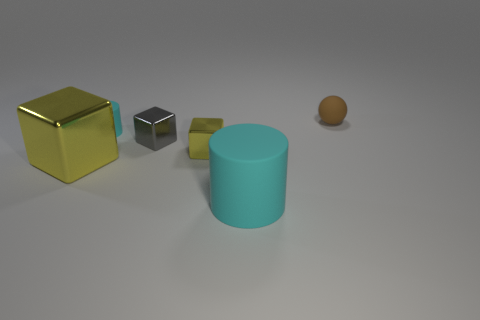Subtract all cyan cylinders. How many were subtracted if there are1cyan cylinders left? 1 Subtract all tiny yellow metal blocks. How many blocks are left? 2 Add 3 cylinders. How many objects exist? 9 Subtract all gray blocks. How many blocks are left? 2 Subtract all yellow spheres. How many yellow cylinders are left? 0 Subtract all brown objects. Subtract all cyan matte cylinders. How many objects are left? 3 Add 6 tiny yellow metallic things. How many tiny yellow metallic things are left? 7 Add 5 blue cylinders. How many blue cylinders exist? 5 Subtract 2 yellow blocks. How many objects are left? 4 Subtract all spheres. How many objects are left? 5 